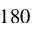Convert formula to latex. <formula><loc_0><loc_0><loc_500><loc_500>1 8 0</formula> 